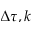<formula> <loc_0><loc_0><loc_500><loc_500>\Delta \tau , k</formula> 